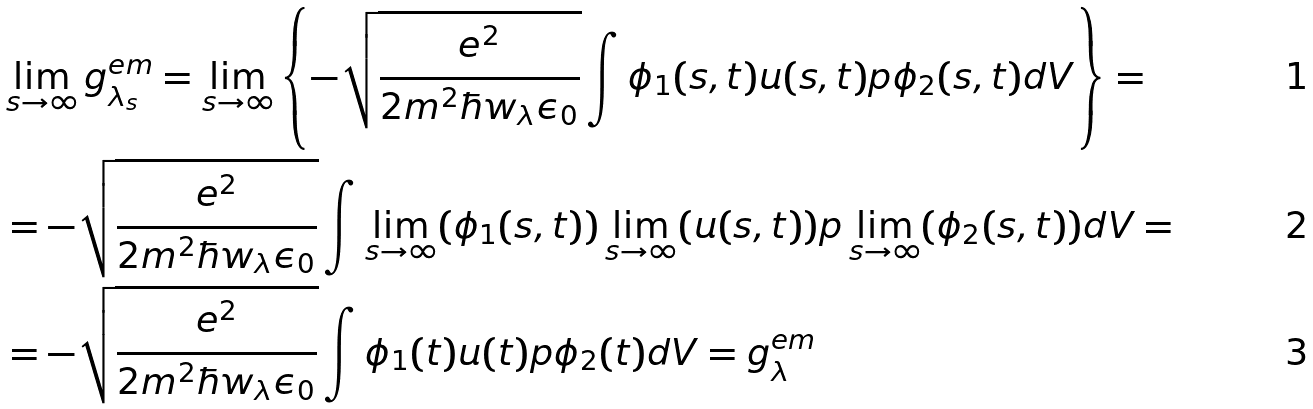Convert formula to latex. <formula><loc_0><loc_0><loc_500><loc_500>& \lim _ { s \to \infty } g ^ { e m } _ { \lambda _ { s } } = \lim _ { s \to \infty } \left \{ - \sqrt { \frac { e ^ { 2 } } { 2 m ^ { 2 } \hbar { w } _ { \lambda } \epsilon _ { 0 } } } \int \phi _ { 1 } ( s , t ) u ( s , t ) p \phi _ { 2 } ( s , t ) d V \right \} = \\ & = - \sqrt { \frac { e ^ { 2 } } { 2 m ^ { 2 } \hbar { w } _ { \lambda } \epsilon _ { 0 } } } \int \lim _ { s \to \infty } ( \phi _ { 1 } ( s , t ) ) \lim _ { s \to \infty } ( u ( s , t ) ) p \lim _ { s \to \infty } ( \phi _ { 2 } ( s , t ) ) d V = \\ & = - \sqrt { \frac { e ^ { 2 } } { 2 m ^ { 2 } \hbar { w } _ { \lambda } \epsilon _ { 0 } } } \int \phi _ { 1 } ( t ) u ( t ) p \phi _ { 2 } ( t ) d V = g ^ { e m } _ { \lambda }</formula> 